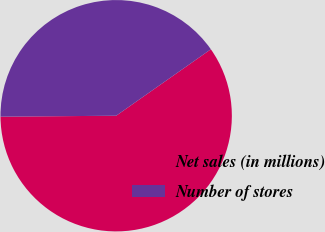<chart> <loc_0><loc_0><loc_500><loc_500><pie_chart><fcel>Net sales (in millions)<fcel>Number of stores<nl><fcel>59.61%<fcel>40.39%<nl></chart> 